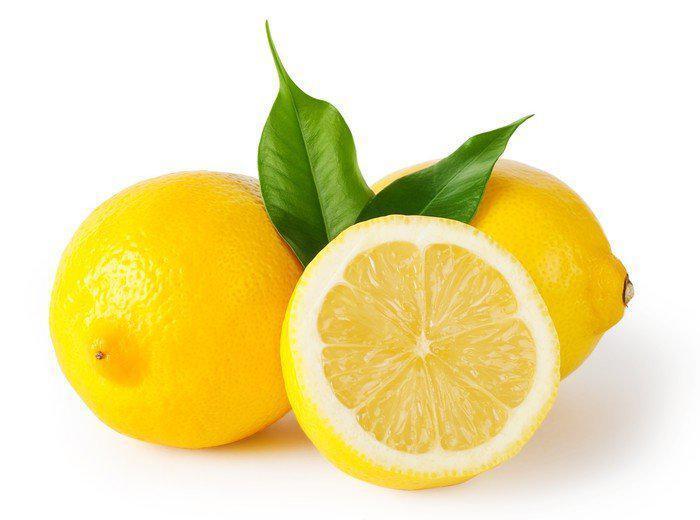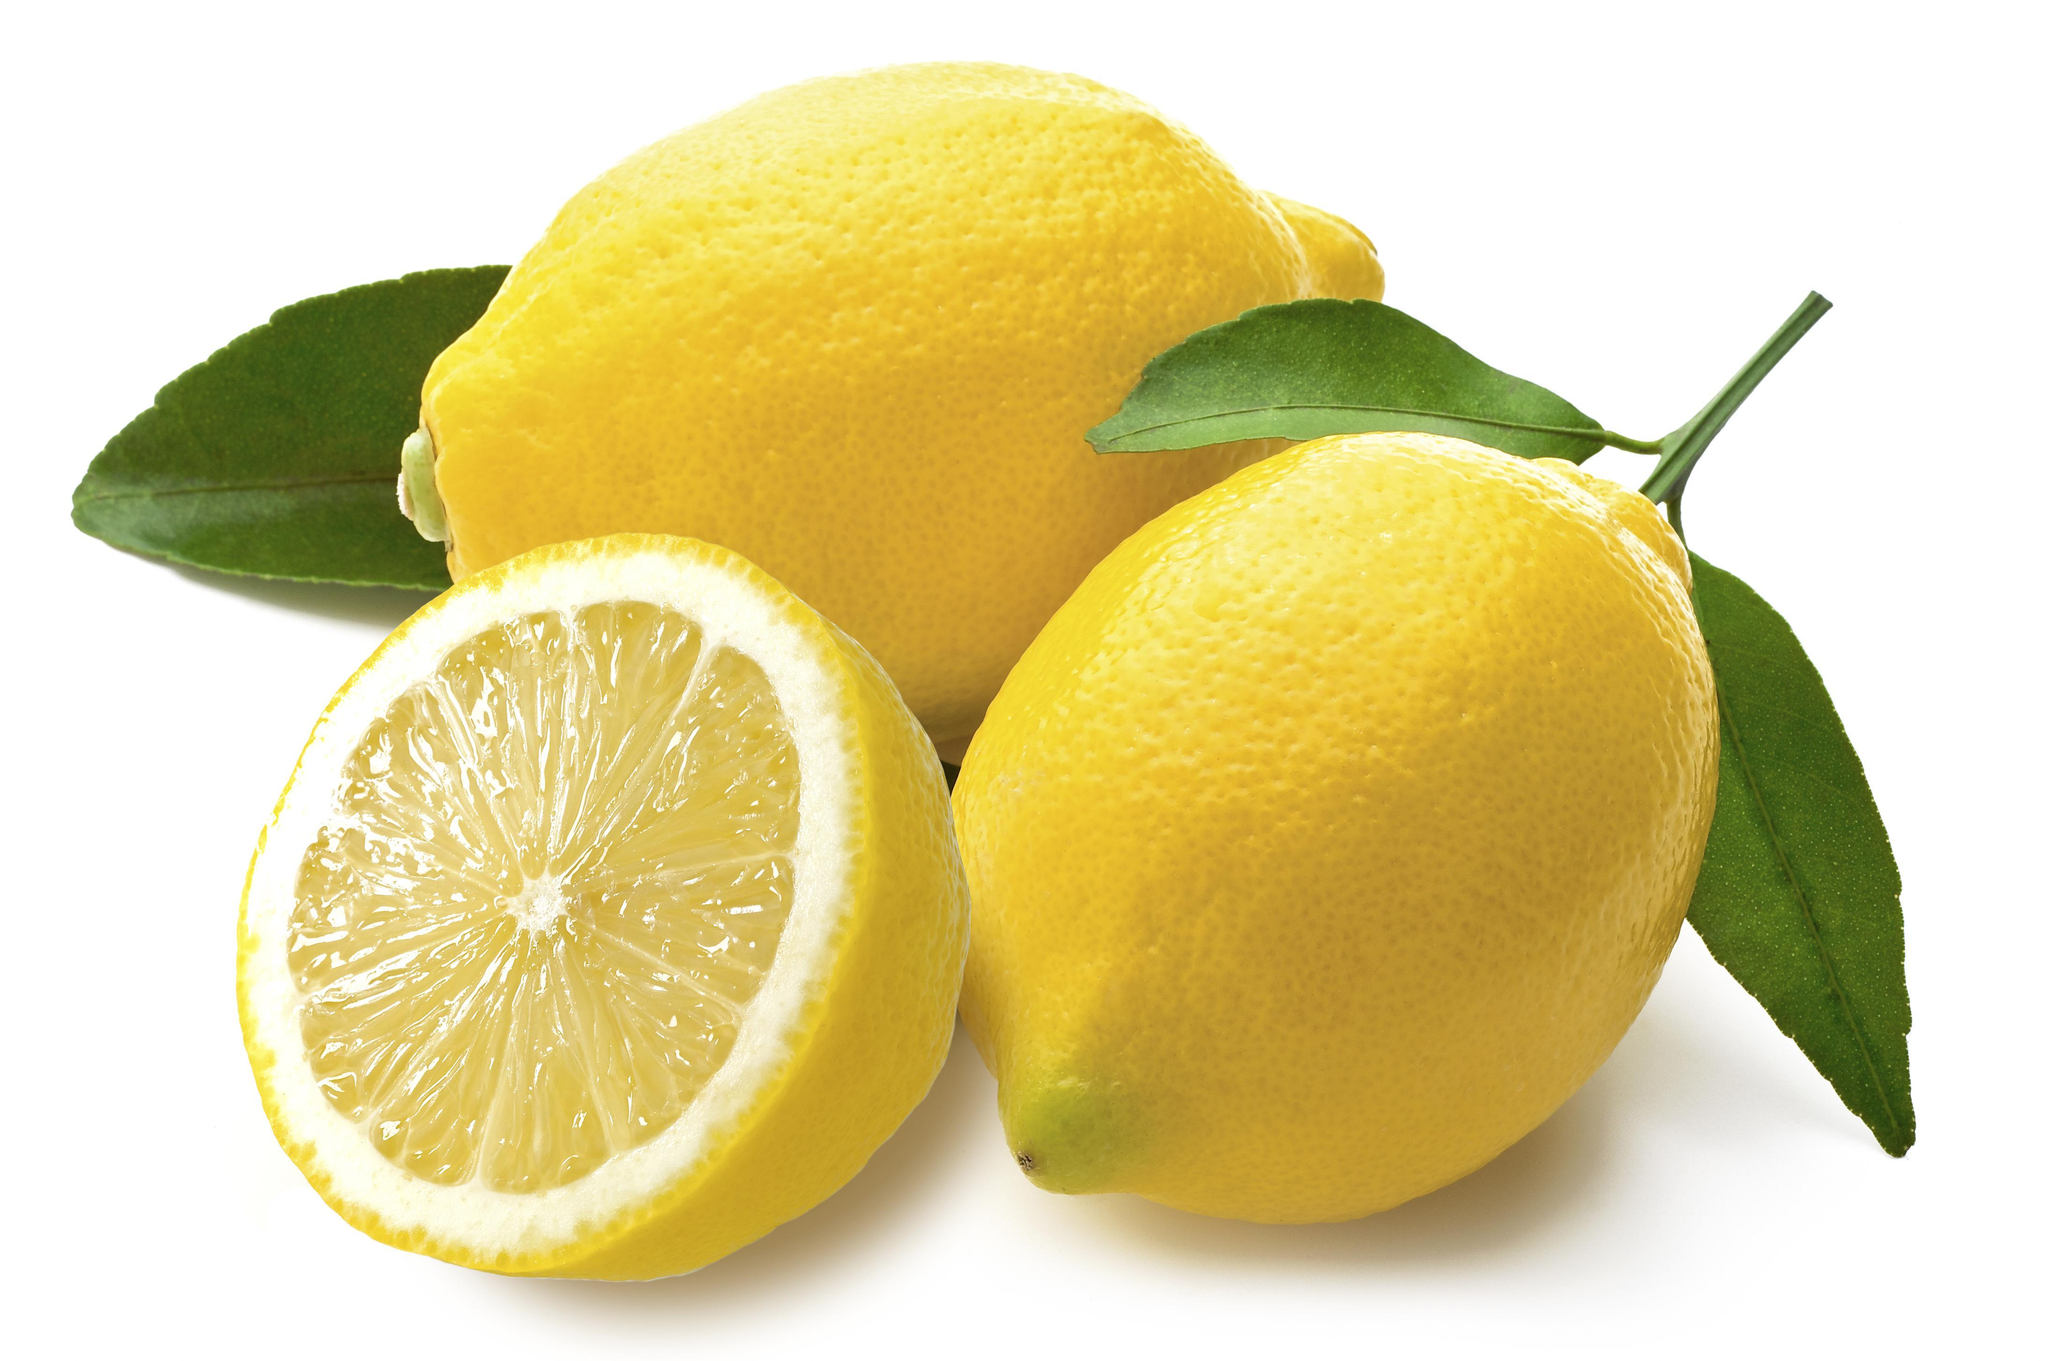The first image is the image on the left, the second image is the image on the right. Examine the images to the left and right. Is the description "There is one image with exactly five green leaves." accurate? Answer yes or no. No. The first image is the image on the left, the second image is the image on the right. Given the left and right images, does the statement "in the left image the lemons are left whole" hold true? Answer yes or no. No. 